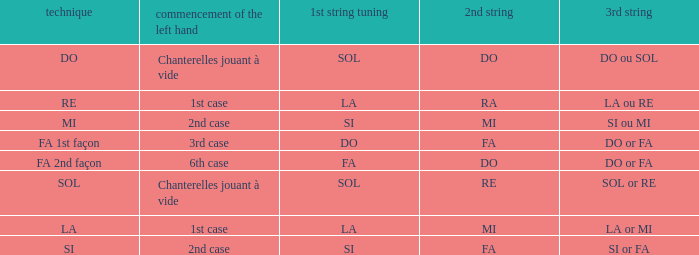What is the 3rd string if the 1st string is in si accord du and the 2nd string is in mi? SI ou MI. 